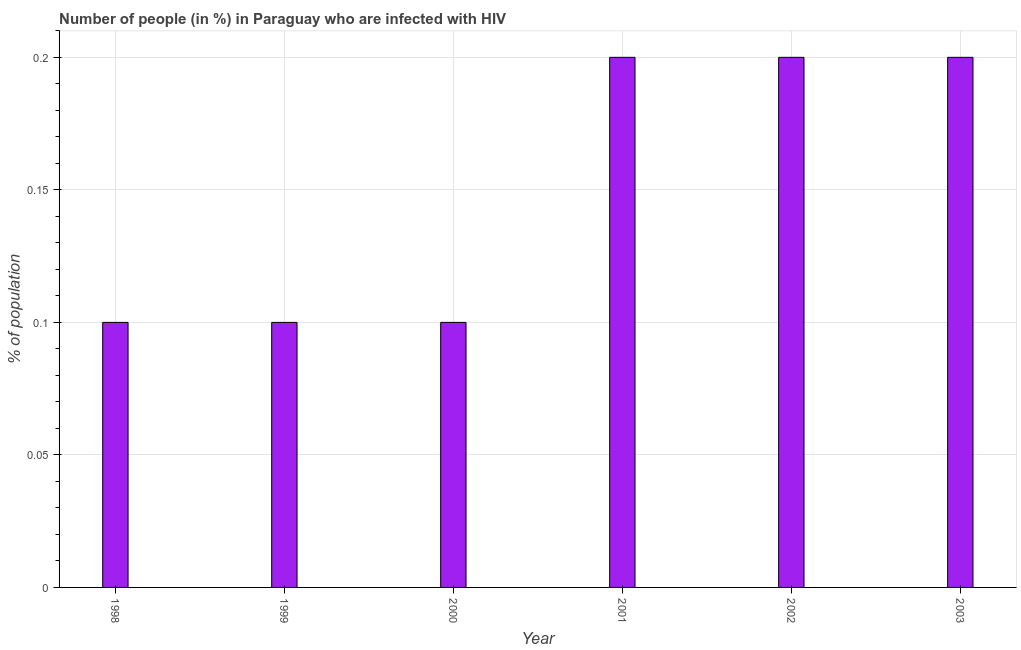Does the graph contain any zero values?
Ensure brevity in your answer.  No. Does the graph contain grids?
Offer a terse response. Yes. What is the title of the graph?
Give a very brief answer. Number of people (in %) in Paraguay who are infected with HIV. What is the label or title of the X-axis?
Ensure brevity in your answer.  Year. What is the label or title of the Y-axis?
Make the answer very short. % of population. In which year was the number of people infected with hiv minimum?
Give a very brief answer. 1998. What is the sum of the number of people infected with hiv?
Your answer should be very brief. 0.9. What is the median number of people infected with hiv?
Provide a short and direct response. 0.15. In how many years, is the number of people infected with hiv greater than 0.13 %?
Give a very brief answer. 3. What is the difference between the highest and the second highest number of people infected with hiv?
Your answer should be compact. 0. Is the sum of the number of people infected with hiv in 2000 and 2001 greater than the maximum number of people infected with hiv across all years?
Offer a terse response. Yes. In how many years, is the number of people infected with hiv greater than the average number of people infected with hiv taken over all years?
Your answer should be compact. 3. How many years are there in the graph?
Make the answer very short. 6. What is the difference between two consecutive major ticks on the Y-axis?
Provide a succinct answer. 0.05. Are the values on the major ticks of Y-axis written in scientific E-notation?
Give a very brief answer. No. What is the % of population in 2001?
Offer a terse response. 0.2. What is the % of population of 2002?
Your response must be concise. 0.2. What is the % of population of 2003?
Provide a short and direct response. 0.2. What is the difference between the % of population in 1998 and 1999?
Your response must be concise. 0. What is the difference between the % of population in 1999 and 2003?
Make the answer very short. -0.1. What is the difference between the % of population in 2000 and 2001?
Provide a short and direct response. -0.1. What is the difference between the % of population in 2001 and 2002?
Ensure brevity in your answer.  0. What is the difference between the % of population in 2001 and 2003?
Offer a terse response. 0. What is the difference between the % of population in 2002 and 2003?
Make the answer very short. 0. What is the ratio of the % of population in 1998 to that in 2001?
Offer a terse response. 0.5. What is the ratio of the % of population in 1998 to that in 2002?
Provide a succinct answer. 0.5. What is the ratio of the % of population in 1999 to that in 2001?
Provide a short and direct response. 0.5. What is the ratio of the % of population in 2000 to that in 2001?
Offer a terse response. 0.5. What is the ratio of the % of population in 2000 to that in 2002?
Your response must be concise. 0.5. What is the ratio of the % of population in 2000 to that in 2003?
Offer a very short reply. 0.5. 